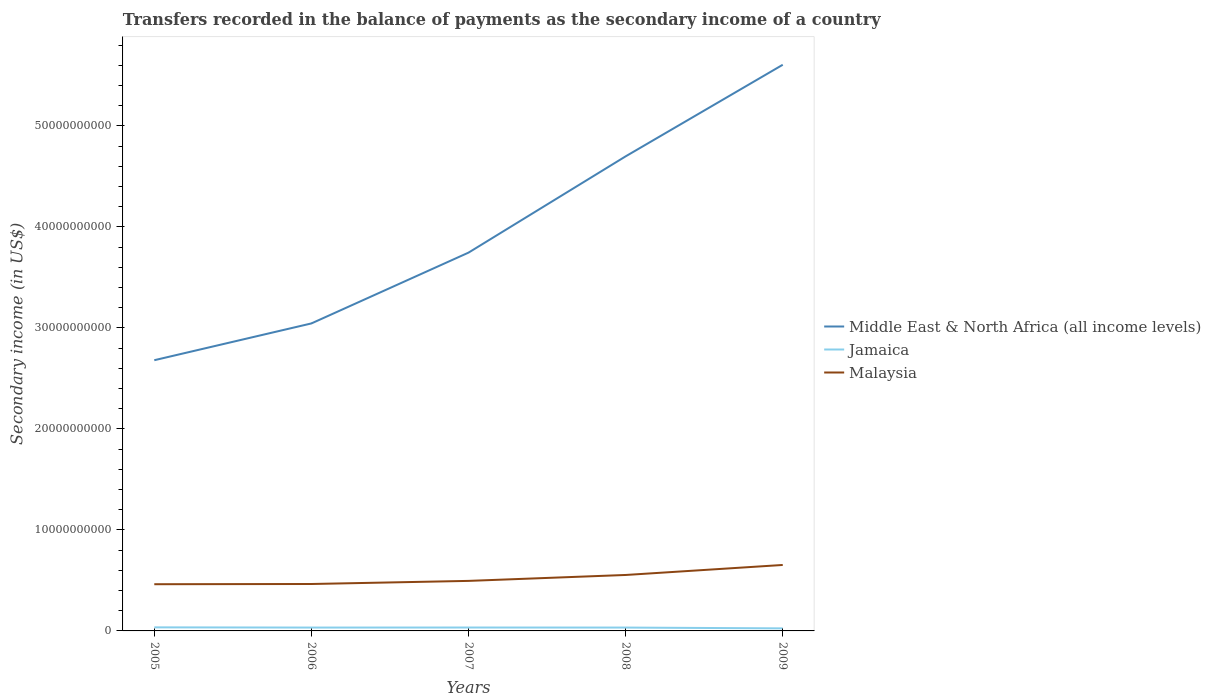Across all years, what is the maximum secondary income of in Malaysia?
Offer a very short reply. 4.62e+09. What is the total secondary income of in Middle East & North Africa (all income levels) in the graph?
Your answer should be compact. -9.53e+09. What is the difference between the highest and the second highest secondary income of in Middle East & North Africa (all income levels)?
Offer a very short reply. 2.93e+1. How many years are there in the graph?
Offer a terse response. 5. What is the difference between two consecutive major ticks on the Y-axis?
Your answer should be compact. 1.00e+1. Are the values on the major ticks of Y-axis written in scientific E-notation?
Provide a succinct answer. No. How many legend labels are there?
Ensure brevity in your answer.  3. What is the title of the graph?
Ensure brevity in your answer.  Transfers recorded in the balance of payments as the secondary income of a country. Does "Guatemala" appear as one of the legend labels in the graph?
Offer a terse response. No. What is the label or title of the X-axis?
Offer a very short reply. Years. What is the label or title of the Y-axis?
Your answer should be compact. Secondary income (in US$). What is the Secondary income (in US$) of Middle East & North Africa (all income levels) in 2005?
Offer a very short reply. 2.68e+1. What is the Secondary income (in US$) in Jamaica in 2005?
Keep it short and to the point. 3.52e+08. What is the Secondary income (in US$) of Malaysia in 2005?
Your answer should be very brief. 4.62e+09. What is the Secondary income (in US$) of Middle East & North Africa (all income levels) in 2006?
Your response must be concise. 3.04e+1. What is the Secondary income (in US$) of Jamaica in 2006?
Make the answer very short. 3.33e+08. What is the Secondary income (in US$) of Malaysia in 2006?
Offer a very short reply. 4.65e+09. What is the Secondary income (in US$) of Middle East & North Africa (all income levels) in 2007?
Offer a terse response. 3.75e+1. What is the Secondary income (in US$) of Jamaica in 2007?
Ensure brevity in your answer.  3.37e+08. What is the Secondary income (in US$) in Malaysia in 2007?
Provide a succinct answer. 4.95e+09. What is the Secondary income (in US$) of Middle East & North Africa (all income levels) in 2008?
Keep it short and to the point. 4.70e+1. What is the Secondary income (in US$) of Jamaica in 2008?
Give a very brief answer. 3.33e+08. What is the Secondary income (in US$) of Malaysia in 2008?
Offer a very short reply. 5.54e+09. What is the Secondary income (in US$) in Middle East & North Africa (all income levels) in 2009?
Provide a succinct answer. 5.61e+1. What is the Secondary income (in US$) in Jamaica in 2009?
Keep it short and to the point. 2.52e+08. What is the Secondary income (in US$) in Malaysia in 2009?
Your response must be concise. 6.53e+09. Across all years, what is the maximum Secondary income (in US$) in Middle East & North Africa (all income levels)?
Offer a terse response. 5.61e+1. Across all years, what is the maximum Secondary income (in US$) of Jamaica?
Ensure brevity in your answer.  3.52e+08. Across all years, what is the maximum Secondary income (in US$) in Malaysia?
Your answer should be very brief. 6.53e+09. Across all years, what is the minimum Secondary income (in US$) of Middle East & North Africa (all income levels)?
Make the answer very short. 2.68e+1. Across all years, what is the minimum Secondary income (in US$) of Jamaica?
Your answer should be compact. 2.52e+08. Across all years, what is the minimum Secondary income (in US$) of Malaysia?
Provide a short and direct response. 4.62e+09. What is the total Secondary income (in US$) of Middle East & North Africa (all income levels) in the graph?
Your answer should be very brief. 1.98e+11. What is the total Secondary income (in US$) of Jamaica in the graph?
Your response must be concise. 1.61e+09. What is the total Secondary income (in US$) of Malaysia in the graph?
Your response must be concise. 2.63e+1. What is the difference between the Secondary income (in US$) in Middle East & North Africa (all income levels) in 2005 and that in 2006?
Give a very brief answer. -3.64e+09. What is the difference between the Secondary income (in US$) of Jamaica in 2005 and that in 2006?
Provide a succinct answer. 1.90e+07. What is the difference between the Secondary income (in US$) of Malaysia in 2005 and that in 2006?
Give a very brief answer. -2.22e+07. What is the difference between the Secondary income (in US$) of Middle East & North Africa (all income levels) in 2005 and that in 2007?
Offer a terse response. -1.07e+1. What is the difference between the Secondary income (in US$) in Jamaica in 2005 and that in 2007?
Provide a succinct answer. 1.47e+07. What is the difference between the Secondary income (in US$) in Malaysia in 2005 and that in 2007?
Your answer should be compact. -3.30e+08. What is the difference between the Secondary income (in US$) of Middle East & North Africa (all income levels) in 2005 and that in 2008?
Your response must be concise. -2.02e+1. What is the difference between the Secondary income (in US$) in Jamaica in 2005 and that in 2008?
Your answer should be very brief. 1.97e+07. What is the difference between the Secondary income (in US$) in Malaysia in 2005 and that in 2008?
Provide a short and direct response. -9.15e+08. What is the difference between the Secondary income (in US$) in Middle East & North Africa (all income levels) in 2005 and that in 2009?
Provide a succinct answer. -2.93e+1. What is the difference between the Secondary income (in US$) of Jamaica in 2005 and that in 2009?
Your answer should be compact. 1.01e+08. What is the difference between the Secondary income (in US$) in Malaysia in 2005 and that in 2009?
Offer a very short reply. -1.91e+09. What is the difference between the Secondary income (in US$) in Middle East & North Africa (all income levels) in 2006 and that in 2007?
Offer a terse response. -7.01e+09. What is the difference between the Secondary income (in US$) of Jamaica in 2006 and that in 2007?
Offer a very short reply. -4.31e+06. What is the difference between the Secondary income (in US$) in Malaysia in 2006 and that in 2007?
Keep it short and to the point. -3.08e+08. What is the difference between the Secondary income (in US$) in Middle East & North Africa (all income levels) in 2006 and that in 2008?
Make the answer very short. -1.65e+1. What is the difference between the Secondary income (in US$) in Jamaica in 2006 and that in 2008?
Provide a succinct answer. 6.49e+05. What is the difference between the Secondary income (in US$) in Malaysia in 2006 and that in 2008?
Offer a terse response. -8.93e+08. What is the difference between the Secondary income (in US$) in Middle East & North Africa (all income levels) in 2006 and that in 2009?
Make the answer very short. -2.56e+1. What is the difference between the Secondary income (in US$) of Jamaica in 2006 and that in 2009?
Your answer should be compact. 8.16e+07. What is the difference between the Secondary income (in US$) in Malaysia in 2006 and that in 2009?
Offer a terse response. -1.88e+09. What is the difference between the Secondary income (in US$) of Middle East & North Africa (all income levels) in 2007 and that in 2008?
Offer a terse response. -9.53e+09. What is the difference between the Secondary income (in US$) of Jamaica in 2007 and that in 2008?
Offer a very short reply. 4.96e+06. What is the difference between the Secondary income (in US$) in Malaysia in 2007 and that in 2008?
Your answer should be very brief. -5.85e+08. What is the difference between the Secondary income (in US$) in Middle East & North Africa (all income levels) in 2007 and that in 2009?
Give a very brief answer. -1.86e+1. What is the difference between the Secondary income (in US$) in Jamaica in 2007 and that in 2009?
Offer a very short reply. 8.59e+07. What is the difference between the Secondary income (in US$) of Malaysia in 2007 and that in 2009?
Give a very brief answer. -1.58e+09. What is the difference between the Secondary income (in US$) in Middle East & North Africa (all income levels) in 2008 and that in 2009?
Your response must be concise. -9.07e+09. What is the difference between the Secondary income (in US$) of Jamaica in 2008 and that in 2009?
Make the answer very short. 8.09e+07. What is the difference between the Secondary income (in US$) of Malaysia in 2008 and that in 2009?
Your answer should be very brief. -9.91e+08. What is the difference between the Secondary income (in US$) of Middle East & North Africa (all income levels) in 2005 and the Secondary income (in US$) of Jamaica in 2006?
Offer a terse response. 2.65e+1. What is the difference between the Secondary income (in US$) in Middle East & North Africa (all income levels) in 2005 and the Secondary income (in US$) in Malaysia in 2006?
Your response must be concise. 2.22e+1. What is the difference between the Secondary income (in US$) in Jamaica in 2005 and the Secondary income (in US$) in Malaysia in 2006?
Offer a very short reply. -4.29e+09. What is the difference between the Secondary income (in US$) of Middle East & North Africa (all income levels) in 2005 and the Secondary income (in US$) of Jamaica in 2007?
Offer a very short reply. 2.65e+1. What is the difference between the Secondary income (in US$) in Middle East & North Africa (all income levels) in 2005 and the Secondary income (in US$) in Malaysia in 2007?
Keep it short and to the point. 2.18e+1. What is the difference between the Secondary income (in US$) in Jamaica in 2005 and the Secondary income (in US$) in Malaysia in 2007?
Give a very brief answer. -4.60e+09. What is the difference between the Secondary income (in US$) in Middle East & North Africa (all income levels) in 2005 and the Secondary income (in US$) in Jamaica in 2008?
Offer a very short reply. 2.65e+1. What is the difference between the Secondary income (in US$) of Middle East & North Africa (all income levels) in 2005 and the Secondary income (in US$) of Malaysia in 2008?
Your answer should be compact. 2.13e+1. What is the difference between the Secondary income (in US$) in Jamaica in 2005 and the Secondary income (in US$) in Malaysia in 2008?
Make the answer very short. -5.19e+09. What is the difference between the Secondary income (in US$) of Middle East & North Africa (all income levels) in 2005 and the Secondary income (in US$) of Jamaica in 2009?
Your answer should be very brief. 2.66e+1. What is the difference between the Secondary income (in US$) of Middle East & North Africa (all income levels) in 2005 and the Secondary income (in US$) of Malaysia in 2009?
Offer a very short reply. 2.03e+1. What is the difference between the Secondary income (in US$) in Jamaica in 2005 and the Secondary income (in US$) in Malaysia in 2009?
Offer a terse response. -6.18e+09. What is the difference between the Secondary income (in US$) in Middle East & North Africa (all income levels) in 2006 and the Secondary income (in US$) in Jamaica in 2007?
Ensure brevity in your answer.  3.01e+1. What is the difference between the Secondary income (in US$) of Middle East & North Africa (all income levels) in 2006 and the Secondary income (in US$) of Malaysia in 2007?
Make the answer very short. 2.55e+1. What is the difference between the Secondary income (in US$) in Jamaica in 2006 and the Secondary income (in US$) in Malaysia in 2007?
Provide a short and direct response. -4.62e+09. What is the difference between the Secondary income (in US$) of Middle East & North Africa (all income levels) in 2006 and the Secondary income (in US$) of Jamaica in 2008?
Provide a succinct answer. 3.01e+1. What is the difference between the Secondary income (in US$) of Middle East & North Africa (all income levels) in 2006 and the Secondary income (in US$) of Malaysia in 2008?
Your answer should be very brief. 2.49e+1. What is the difference between the Secondary income (in US$) of Jamaica in 2006 and the Secondary income (in US$) of Malaysia in 2008?
Make the answer very short. -5.21e+09. What is the difference between the Secondary income (in US$) in Middle East & North Africa (all income levels) in 2006 and the Secondary income (in US$) in Jamaica in 2009?
Keep it short and to the point. 3.02e+1. What is the difference between the Secondary income (in US$) of Middle East & North Africa (all income levels) in 2006 and the Secondary income (in US$) of Malaysia in 2009?
Your answer should be compact. 2.39e+1. What is the difference between the Secondary income (in US$) of Jamaica in 2006 and the Secondary income (in US$) of Malaysia in 2009?
Offer a very short reply. -6.20e+09. What is the difference between the Secondary income (in US$) of Middle East & North Africa (all income levels) in 2007 and the Secondary income (in US$) of Jamaica in 2008?
Provide a succinct answer. 3.71e+1. What is the difference between the Secondary income (in US$) in Middle East & North Africa (all income levels) in 2007 and the Secondary income (in US$) in Malaysia in 2008?
Offer a terse response. 3.19e+1. What is the difference between the Secondary income (in US$) in Jamaica in 2007 and the Secondary income (in US$) in Malaysia in 2008?
Offer a very short reply. -5.20e+09. What is the difference between the Secondary income (in US$) of Middle East & North Africa (all income levels) in 2007 and the Secondary income (in US$) of Jamaica in 2009?
Offer a very short reply. 3.72e+1. What is the difference between the Secondary income (in US$) in Middle East & North Africa (all income levels) in 2007 and the Secondary income (in US$) in Malaysia in 2009?
Give a very brief answer. 3.09e+1. What is the difference between the Secondary income (in US$) in Jamaica in 2007 and the Secondary income (in US$) in Malaysia in 2009?
Your answer should be compact. -6.19e+09. What is the difference between the Secondary income (in US$) in Middle East & North Africa (all income levels) in 2008 and the Secondary income (in US$) in Jamaica in 2009?
Provide a short and direct response. 4.67e+1. What is the difference between the Secondary income (in US$) in Middle East & North Africa (all income levels) in 2008 and the Secondary income (in US$) in Malaysia in 2009?
Your answer should be very brief. 4.05e+1. What is the difference between the Secondary income (in US$) in Jamaica in 2008 and the Secondary income (in US$) in Malaysia in 2009?
Keep it short and to the point. -6.20e+09. What is the average Secondary income (in US$) in Middle East & North Africa (all income levels) per year?
Your response must be concise. 3.95e+1. What is the average Secondary income (in US$) of Jamaica per year?
Keep it short and to the point. 3.21e+08. What is the average Secondary income (in US$) in Malaysia per year?
Make the answer very short. 5.26e+09. In the year 2005, what is the difference between the Secondary income (in US$) in Middle East & North Africa (all income levels) and Secondary income (in US$) in Jamaica?
Give a very brief answer. 2.65e+1. In the year 2005, what is the difference between the Secondary income (in US$) in Middle East & North Africa (all income levels) and Secondary income (in US$) in Malaysia?
Ensure brevity in your answer.  2.22e+1. In the year 2005, what is the difference between the Secondary income (in US$) of Jamaica and Secondary income (in US$) of Malaysia?
Make the answer very short. -4.27e+09. In the year 2006, what is the difference between the Secondary income (in US$) of Middle East & North Africa (all income levels) and Secondary income (in US$) of Jamaica?
Keep it short and to the point. 3.01e+1. In the year 2006, what is the difference between the Secondary income (in US$) of Middle East & North Africa (all income levels) and Secondary income (in US$) of Malaysia?
Make the answer very short. 2.58e+1. In the year 2006, what is the difference between the Secondary income (in US$) of Jamaica and Secondary income (in US$) of Malaysia?
Offer a very short reply. -4.31e+09. In the year 2007, what is the difference between the Secondary income (in US$) of Middle East & North Africa (all income levels) and Secondary income (in US$) of Jamaica?
Your answer should be very brief. 3.71e+1. In the year 2007, what is the difference between the Secondary income (in US$) in Middle East & North Africa (all income levels) and Secondary income (in US$) in Malaysia?
Keep it short and to the point. 3.25e+1. In the year 2007, what is the difference between the Secondary income (in US$) of Jamaica and Secondary income (in US$) of Malaysia?
Provide a short and direct response. -4.62e+09. In the year 2008, what is the difference between the Secondary income (in US$) in Middle East & North Africa (all income levels) and Secondary income (in US$) in Jamaica?
Keep it short and to the point. 4.67e+1. In the year 2008, what is the difference between the Secondary income (in US$) in Middle East & North Africa (all income levels) and Secondary income (in US$) in Malaysia?
Offer a terse response. 4.14e+1. In the year 2008, what is the difference between the Secondary income (in US$) in Jamaica and Secondary income (in US$) in Malaysia?
Offer a terse response. -5.21e+09. In the year 2009, what is the difference between the Secondary income (in US$) of Middle East & North Africa (all income levels) and Secondary income (in US$) of Jamaica?
Your answer should be very brief. 5.58e+1. In the year 2009, what is the difference between the Secondary income (in US$) in Middle East & North Africa (all income levels) and Secondary income (in US$) in Malaysia?
Provide a succinct answer. 4.95e+1. In the year 2009, what is the difference between the Secondary income (in US$) in Jamaica and Secondary income (in US$) in Malaysia?
Your answer should be compact. -6.28e+09. What is the ratio of the Secondary income (in US$) of Middle East & North Africa (all income levels) in 2005 to that in 2006?
Keep it short and to the point. 0.88. What is the ratio of the Secondary income (in US$) in Jamaica in 2005 to that in 2006?
Your response must be concise. 1.06. What is the ratio of the Secondary income (in US$) in Malaysia in 2005 to that in 2006?
Provide a succinct answer. 1. What is the ratio of the Secondary income (in US$) of Middle East & North Africa (all income levels) in 2005 to that in 2007?
Keep it short and to the point. 0.72. What is the ratio of the Secondary income (in US$) of Jamaica in 2005 to that in 2007?
Make the answer very short. 1.04. What is the ratio of the Secondary income (in US$) of Malaysia in 2005 to that in 2007?
Your answer should be compact. 0.93. What is the ratio of the Secondary income (in US$) in Middle East & North Africa (all income levels) in 2005 to that in 2008?
Your response must be concise. 0.57. What is the ratio of the Secondary income (in US$) of Jamaica in 2005 to that in 2008?
Your answer should be compact. 1.06. What is the ratio of the Secondary income (in US$) in Malaysia in 2005 to that in 2008?
Provide a succinct answer. 0.83. What is the ratio of the Secondary income (in US$) of Middle East & North Africa (all income levels) in 2005 to that in 2009?
Ensure brevity in your answer.  0.48. What is the ratio of the Secondary income (in US$) of Jamaica in 2005 to that in 2009?
Ensure brevity in your answer.  1.4. What is the ratio of the Secondary income (in US$) in Malaysia in 2005 to that in 2009?
Make the answer very short. 0.71. What is the ratio of the Secondary income (in US$) in Middle East & North Africa (all income levels) in 2006 to that in 2007?
Keep it short and to the point. 0.81. What is the ratio of the Secondary income (in US$) in Jamaica in 2006 to that in 2007?
Your response must be concise. 0.99. What is the ratio of the Secondary income (in US$) in Malaysia in 2006 to that in 2007?
Make the answer very short. 0.94. What is the ratio of the Secondary income (in US$) in Middle East & North Africa (all income levels) in 2006 to that in 2008?
Keep it short and to the point. 0.65. What is the ratio of the Secondary income (in US$) in Jamaica in 2006 to that in 2008?
Make the answer very short. 1. What is the ratio of the Secondary income (in US$) of Malaysia in 2006 to that in 2008?
Offer a terse response. 0.84. What is the ratio of the Secondary income (in US$) in Middle East & North Africa (all income levels) in 2006 to that in 2009?
Provide a short and direct response. 0.54. What is the ratio of the Secondary income (in US$) in Jamaica in 2006 to that in 2009?
Offer a very short reply. 1.32. What is the ratio of the Secondary income (in US$) in Malaysia in 2006 to that in 2009?
Give a very brief answer. 0.71. What is the ratio of the Secondary income (in US$) of Middle East & North Africa (all income levels) in 2007 to that in 2008?
Make the answer very short. 0.8. What is the ratio of the Secondary income (in US$) in Jamaica in 2007 to that in 2008?
Give a very brief answer. 1.01. What is the ratio of the Secondary income (in US$) of Malaysia in 2007 to that in 2008?
Offer a terse response. 0.89. What is the ratio of the Secondary income (in US$) in Middle East & North Africa (all income levels) in 2007 to that in 2009?
Keep it short and to the point. 0.67. What is the ratio of the Secondary income (in US$) in Jamaica in 2007 to that in 2009?
Provide a succinct answer. 1.34. What is the ratio of the Secondary income (in US$) in Malaysia in 2007 to that in 2009?
Your response must be concise. 0.76. What is the ratio of the Secondary income (in US$) in Middle East & North Africa (all income levels) in 2008 to that in 2009?
Offer a terse response. 0.84. What is the ratio of the Secondary income (in US$) in Jamaica in 2008 to that in 2009?
Provide a short and direct response. 1.32. What is the ratio of the Secondary income (in US$) in Malaysia in 2008 to that in 2009?
Offer a very short reply. 0.85. What is the difference between the highest and the second highest Secondary income (in US$) in Middle East & North Africa (all income levels)?
Provide a succinct answer. 9.07e+09. What is the difference between the highest and the second highest Secondary income (in US$) in Jamaica?
Offer a very short reply. 1.47e+07. What is the difference between the highest and the second highest Secondary income (in US$) in Malaysia?
Provide a short and direct response. 9.91e+08. What is the difference between the highest and the lowest Secondary income (in US$) in Middle East & North Africa (all income levels)?
Provide a short and direct response. 2.93e+1. What is the difference between the highest and the lowest Secondary income (in US$) of Jamaica?
Provide a short and direct response. 1.01e+08. What is the difference between the highest and the lowest Secondary income (in US$) in Malaysia?
Offer a terse response. 1.91e+09. 